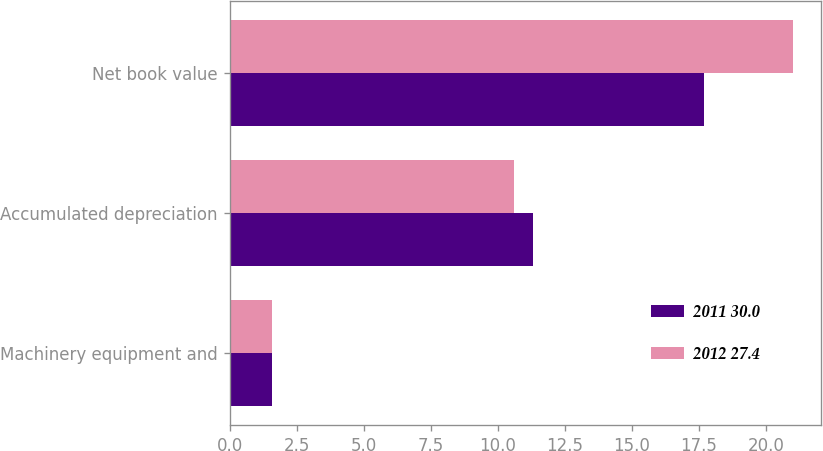Convert chart to OTSL. <chart><loc_0><loc_0><loc_500><loc_500><stacked_bar_chart><ecel><fcel>Machinery equipment and<fcel>Accumulated depreciation<fcel>Net book value<nl><fcel>2011 30.0<fcel>1.6<fcel>11.3<fcel>17.7<nl><fcel>2012 27.4<fcel>1.6<fcel>10.6<fcel>21<nl></chart> 